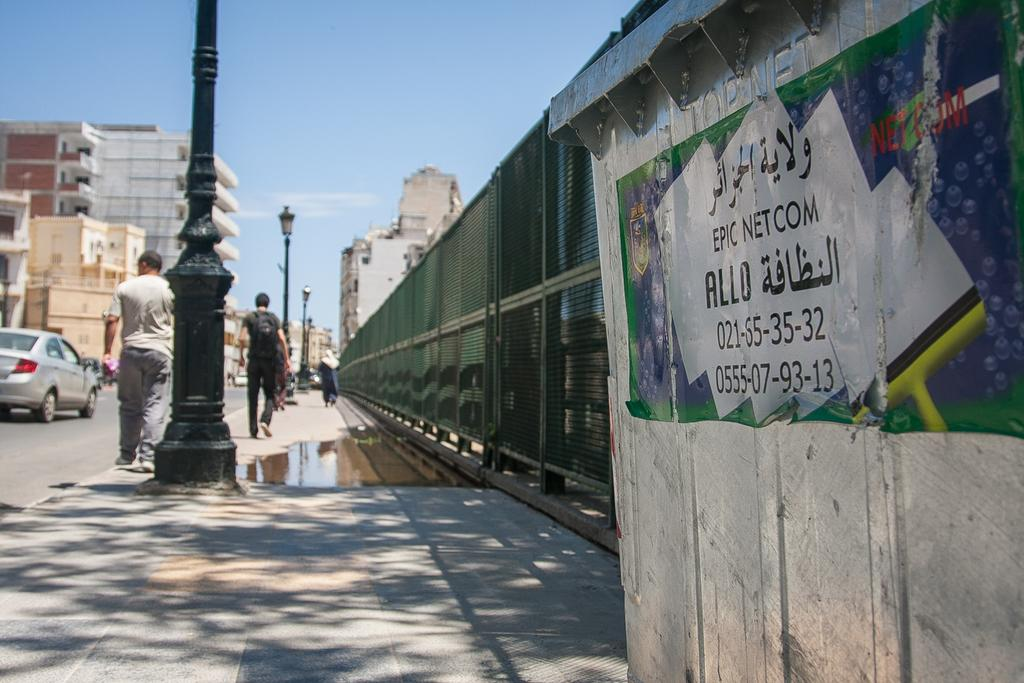<image>
Present a compact description of the photo's key features. A city street and a sign that says epic net. com. 